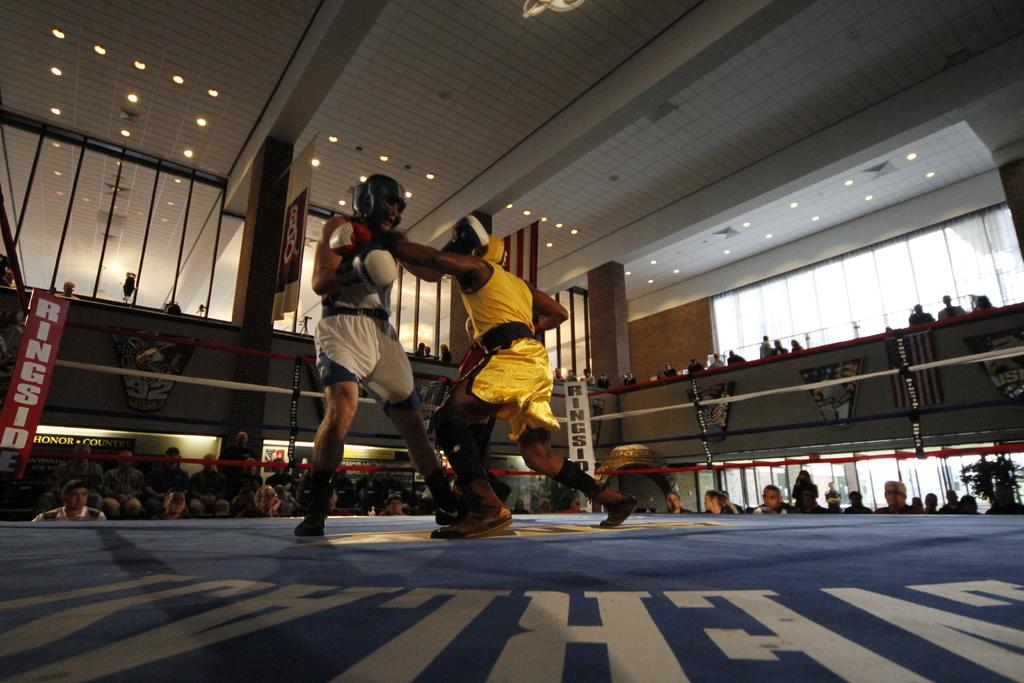Provide a one-sentence caption for the provided image. A red and white sign that says RINGSIDE can be seen behind the fighters. 